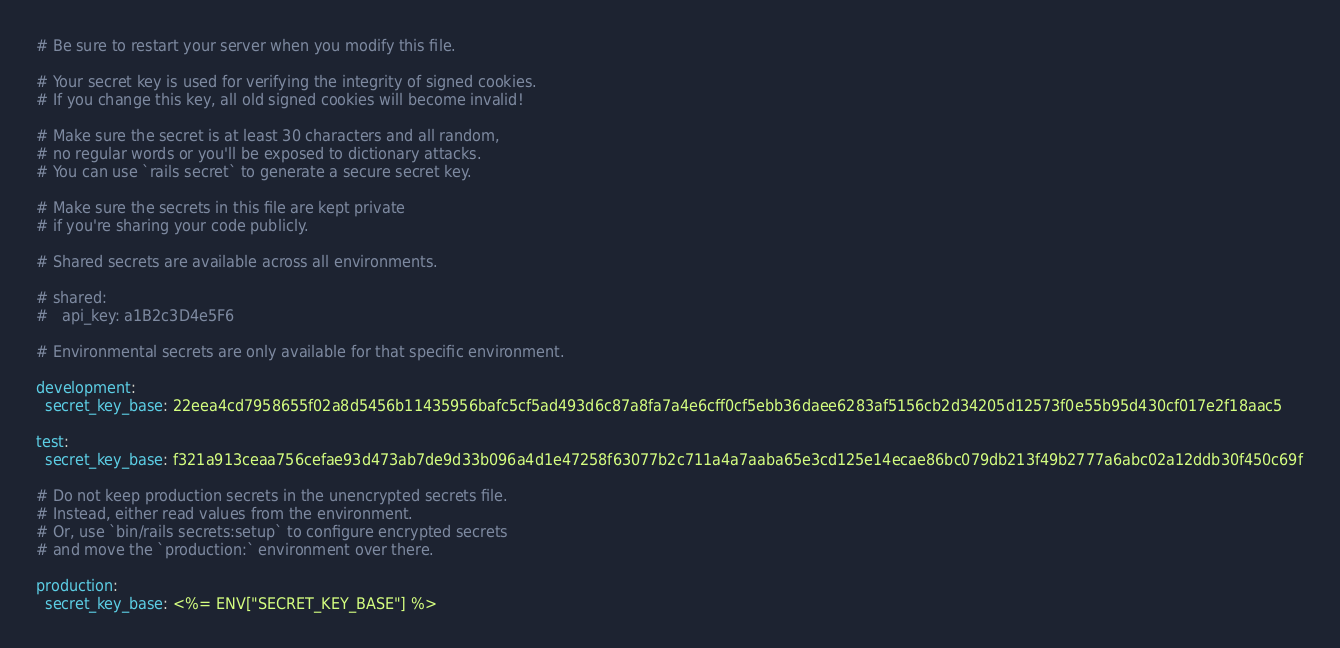<code> <loc_0><loc_0><loc_500><loc_500><_YAML_># Be sure to restart your server when you modify this file.

# Your secret key is used for verifying the integrity of signed cookies.
# If you change this key, all old signed cookies will become invalid!

# Make sure the secret is at least 30 characters and all random,
# no regular words or you'll be exposed to dictionary attacks.
# You can use `rails secret` to generate a secure secret key.

# Make sure the secrets in this file are kept private
# if you're sharing your code publicly.

# Shared secrets are available across all environments.

# shared:
#   api_key: a1B2c3D4e5F6

# Environmental secrets are only available for that specific environment.

development:
  secret_key_base: 22eea4cd7958655f02a8d5456b11435956bafc5cf5ad493d6c87a8fa7a4e6cff0cf5ebb36daee6283af5156cb2d34205d12573f0e55b95d430cf017e2f18aac5

test:
  secret_key_base: f321a913ceaa756cefae93d473ab7de9d33b096a4d1e47258f63077b2c711a4a7aaba65e3cd125e14ecae86bc079db213f49b2777a6abc02a12ddb30f450c69f

# Do not keep production secrets in the unencrypted secrets file.
# Instead, either read values from the environment.
# Or, use `bin/rails secrets:setup` to configure encrypted secrets
# and move the `production:` environment over there.

production:
  secret_key_base: <%= ENV["SECRET_KEY_BASE"] %>
</code> 